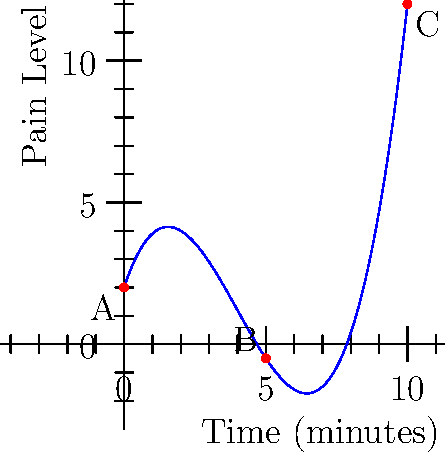During a therapy session, a patient's pain level is modeled by the function $f(x) = 0.1x^3 - 1.2x^2 + 3x + 2$, where $x$ represents the time in minutes and $f(x)$ represents the pain level on a scale of 0 to 10. Based on the graph, at which point (A, B, or C) does the patient experience the lowest pain level, and what is the approximate time this occurs? To find the point with the lowest pain level, we need to analyze the graph:

1. Point A represents the start of the session (x = 0 minutes).
2. Point B is approximately in the middle of the session (x ≈ 5 minutes).
3. Point C represents the end of the session (x = 10 minutes).

By observing the graph:
1. The curve starts at a moderate pain level (Point A).
2. It decreases to a minimum point (Point B).
3. Then it increases again towards the end (Point C).

The lowest point on the curve corresponds to the minimum pain level, which occurs at Point B.

To find the approximate time:
1. Point B appears to be roughly halfway between 0 and 10 minutes on the x-axis.
2. This corresponds to approximately 5 minutes into the session.

Therefore, the patient experiences the lowest pain level at Point B, which occurs approximately 5 minutes into the therapy session.
Answer: Point B, approximately 5 minutes 